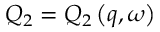Convert formula to latex. <formula><loc_0><loc_0><loc_500><loc_500>Q _ { 2 } = Q _ { 2 } \left ( q , \omega \right )</formula> 